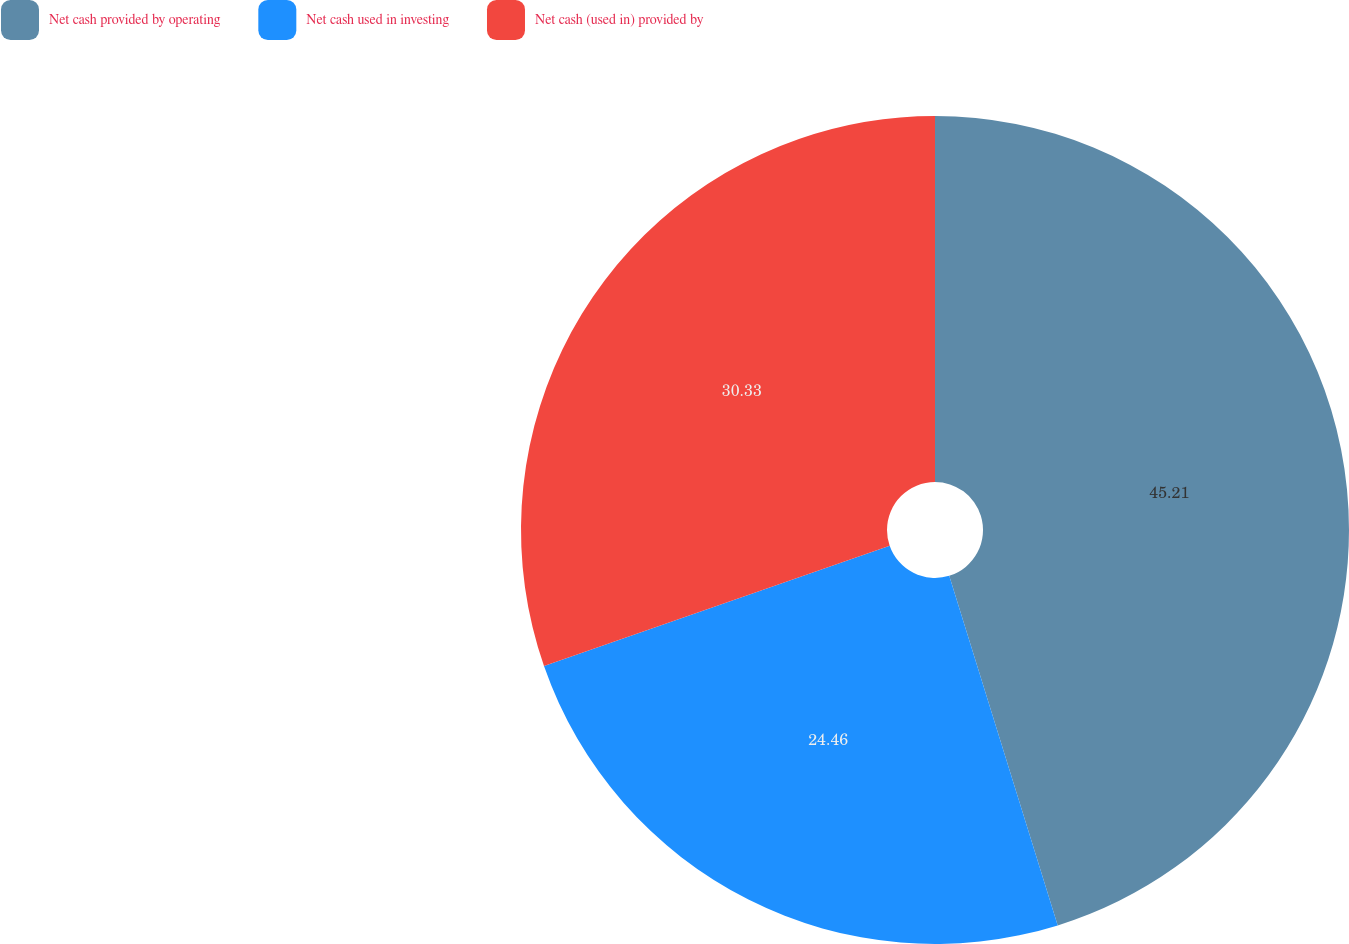Convert chart to OTSL. <chart><loc_0><loc_0><loc_500><loc_500><pie_chart><fcel>Net cash provided by operating<fcel>Net cash used in investing<fcel>Net cash (used in) provided by<nl><fcel>45.21%<fcel>24.46%<fcel>30.33%<nl></chart> 